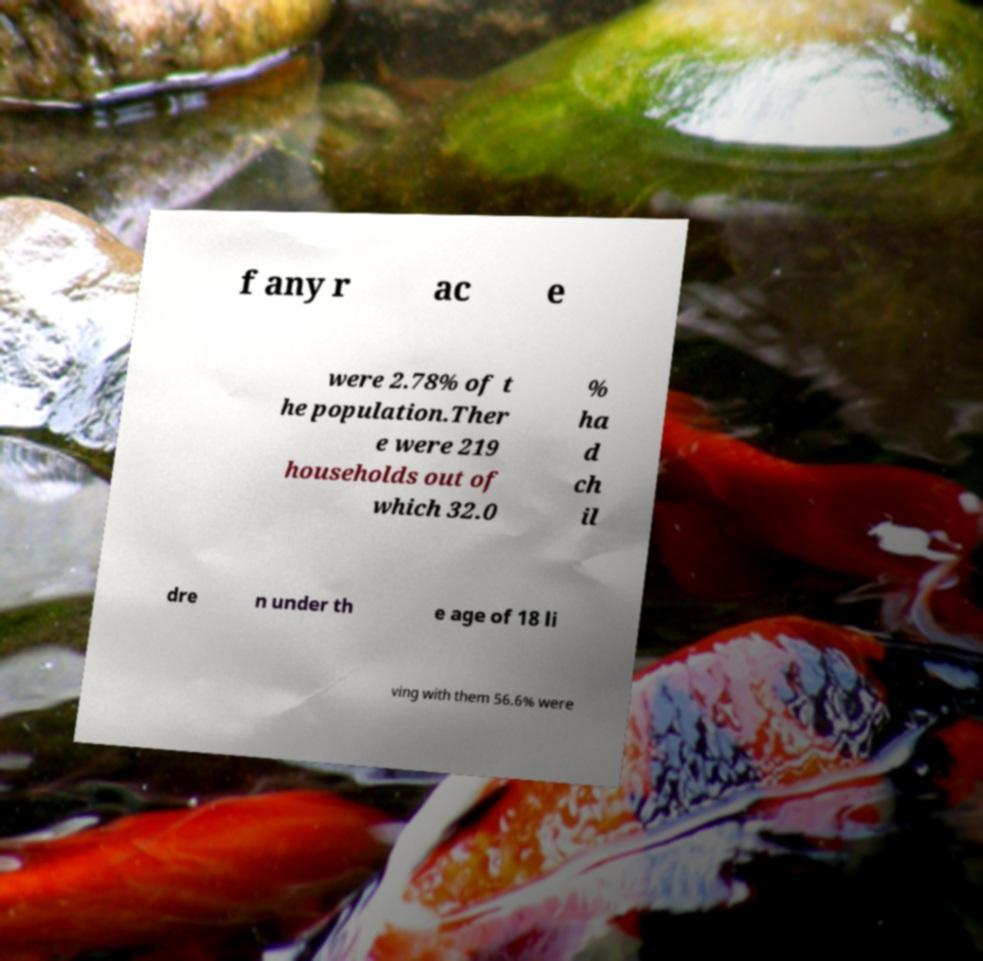Could you assist in decoding the text presented in this image and type it out clearly? f any r ac e were 2.78% of t he population.Ther e were 219 households out of which 32.0 % ha d ch il dre n under th e age of 18 li ving with them 56.6% were 